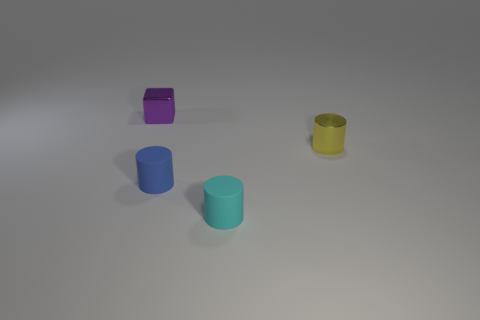How many small blue matte objects have the same shape as the cyan rubber thing?
Your response must be concise. 1. What is the shape of the tiny purple thing?
Offer a very short reply. Cube. Is the number of small red spheres less than the number of cylinders?
Provide a short and direct response. Yes. Are there any other things that are the same size as the yellow metallic cylinder?
Give a very brief answer. Yes. What material is the tiny cyan thing that is the same shape as the blue thing?
Keep it short and to the point. Rubber. Are there more gray metal cubes than cyan matte cylinders?
Your answer should be very brief. No. How many other objects are there of the same color as the metallic cylinder?
Give a very brief answer. 0. Do the cyan object and the tiny object behind the tiny yellow metallic cylinder have the same material?
Offer a very short reply. No. There is a tiny shiny object on the left side of the metallic object that is to the right of the purple metallic cube; what number of purple metallic cubes are in front of it?
Your answer should be very brief. 0. Is the number of matte objects on the right side of the small yellow cylinder less than the number of small rubber cylinders that are behind the cyan matte cylinder?
Keep it short and to the point. Yes. 